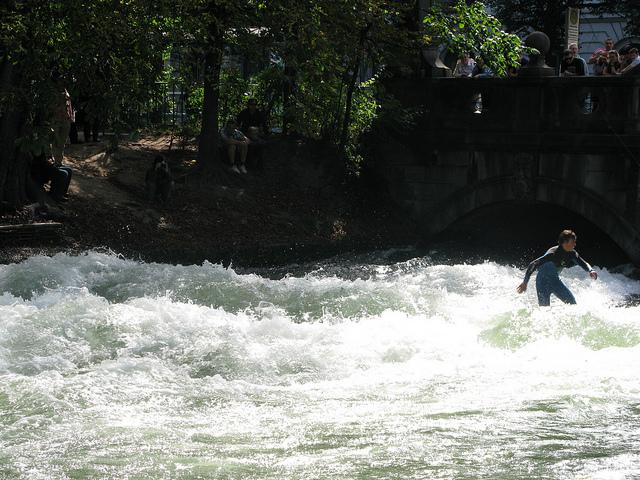Is the water knee deep?
Write a very short answer. Yes. How many waves are in the river?
Short answer required. 2. Is the person wearing a bathing suit?
Give a very brief answer. No. 